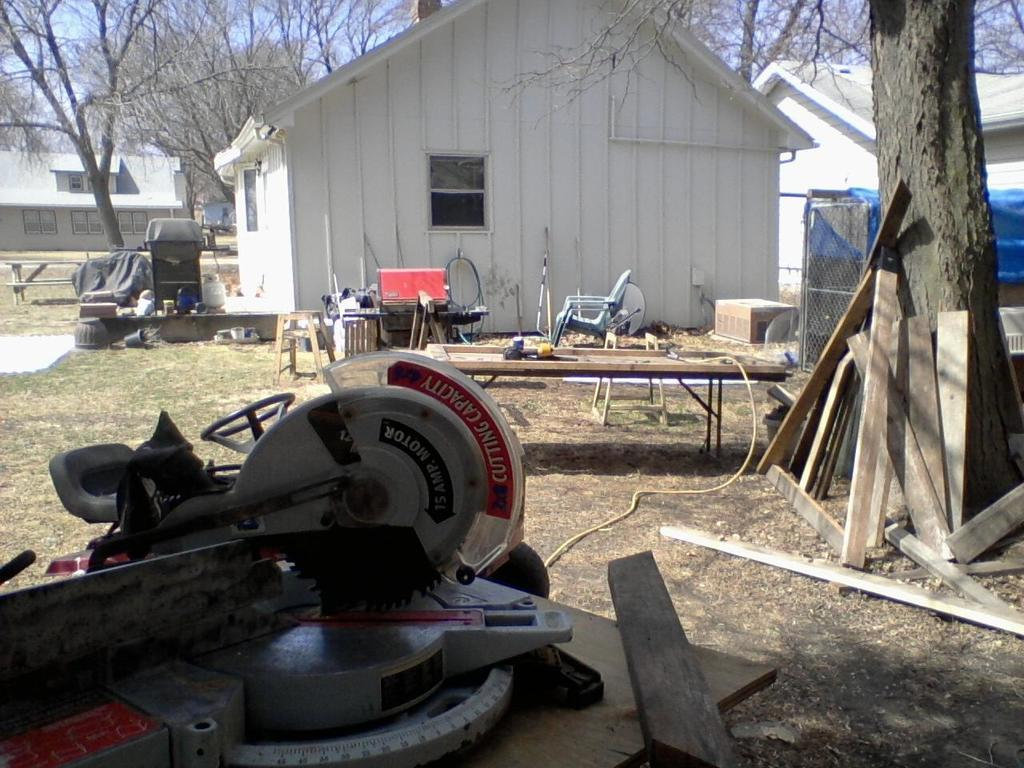What is the main object on the wooden surface in the image? The fact does not specify the main object on the wooden surface, but there is an object present on it. What type of furniture can be seen in the image? There is a stool and a chair in the image. What material is used for the flooring in the image? The wooden planks in the image suggest that the flooring is made of wood. What else is present on the ground in the image? There are objects on the ground in the image, but the fact does not specify what they are. What type of structures are visible in the image? There are sheds in the image. What type of natural elements are visible in the image? There are trees in the image. What is visible in the background of the image? The sky is visible in the background of the image. What type of comb is being used to style the trees in the image? There is no comb present in the image, and the trees are not being styled. What month is it in the image? The fact does not provide any information about the month or time of year in the image. 